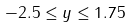Convert formula to latex. <formula><loc_0><loc_0><loc_500><loc_500>- 2 . 5 \leq y \leq 1 . 7 5</formula> 